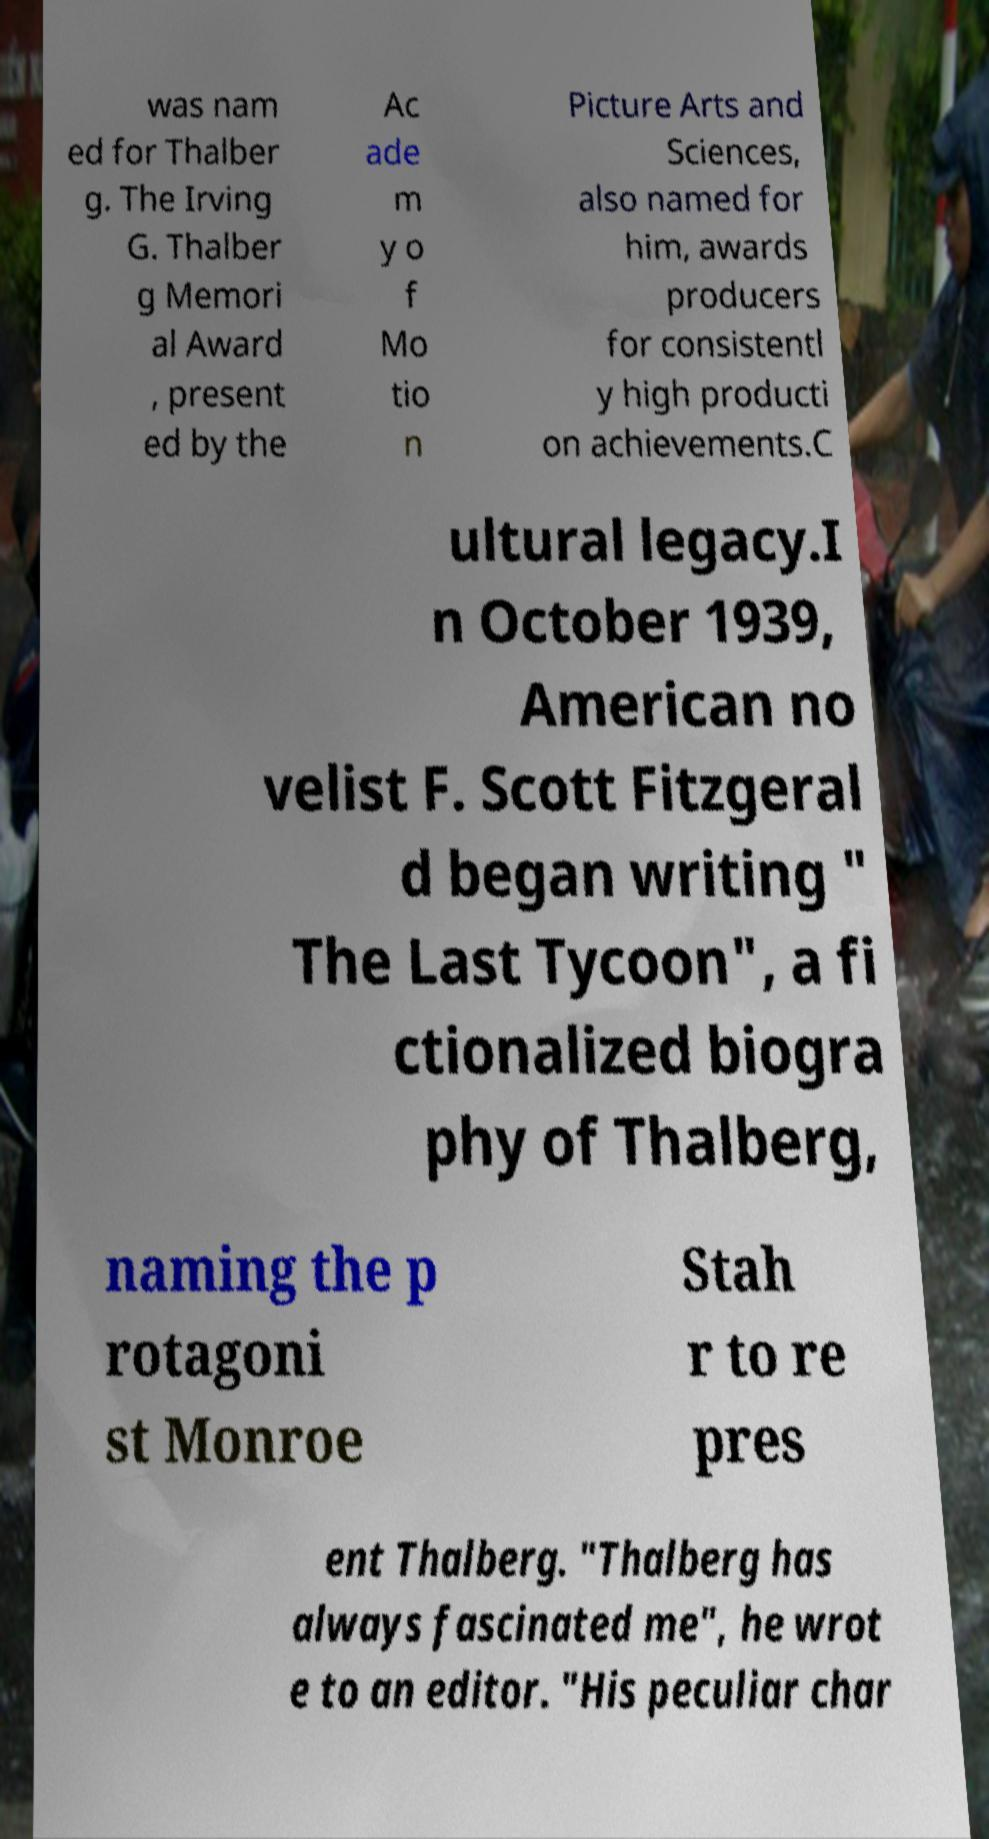Please read and relay the text visible in this image. What does it say? was nam ed for Thalber g. The Irving G. Thalber g Memori al Award , present ed by the Ac ade m y o f Mo tio n Picture Arts and Sciences, also named for him, awards producers for consistentl y high producti on achievements.C ultural legacy.I n October 1939, American no velist F. Scott Fitzgeral d began writing " The Last Tycoon", a fi ctionalized biogra phy of Thalberg, naming the p rotagoni st Monroe Stah r to re pres ent Thalberg. "Thalberg has always fascinated me", he wrot e to an editor. "His peculiar char 